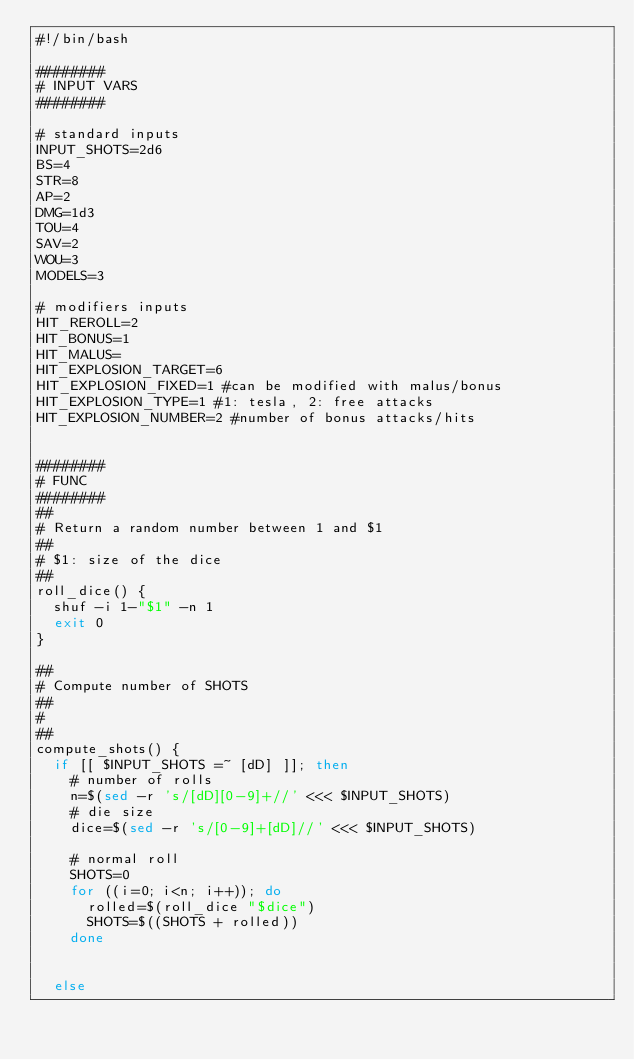Convert code to text. <code><loc_0><loc_0><loc_500><loc_500><_Bash_>#!/bin/bash

########
# INPUT VARS
########

# standard inputs
INPUT_SHOTS=2d6
BS=4
STR=8
AP=2
DMG=1d3
TOU=4
SAV=2
WOU=3
MODELS=3

# modifiers inputs
HIT_REROLL=2
HIT_BONUS=1
HIT_MALUS=
HIT_EXPLOSION_TARGET=6
HIT_EXPLOSION_FIXED=1 #can be modified with malus/bonus
HIT_EXPLOSION_TYPE=1 #1: tesla, 2: free attacks
HIT_EXPLOSION_NUMBER=2 #number of bonus attacks/hits


########
# FUNC
########
##
# Return a random number between 1 and $1
##
# $1: size of the dice
##
roll_dice() {
  shuf -i 1-"$1" -n 1
  exit 0
}

##
# Compute number of SHOTS
##
#
##
compute_shots() {
  if [[ $INPUT_SHOTS =~ [dD] ]]; then
    # number of rolls
    n=$(sed -r 's/[dD][0-9]+//' <<< $INPUT_SHOTS)
    # die size
    dice=$(sed -r 's/[0-9]+[dD]//' <<< $INPUT_SHOTS)

    # normal roll
    SHOTS=0
    for ((i=0; i<n; i++)); do
      rolled=$(roll_dice "$dice")
      SHOTS=$((SHOTS + rolled))
    done


  else</code> 